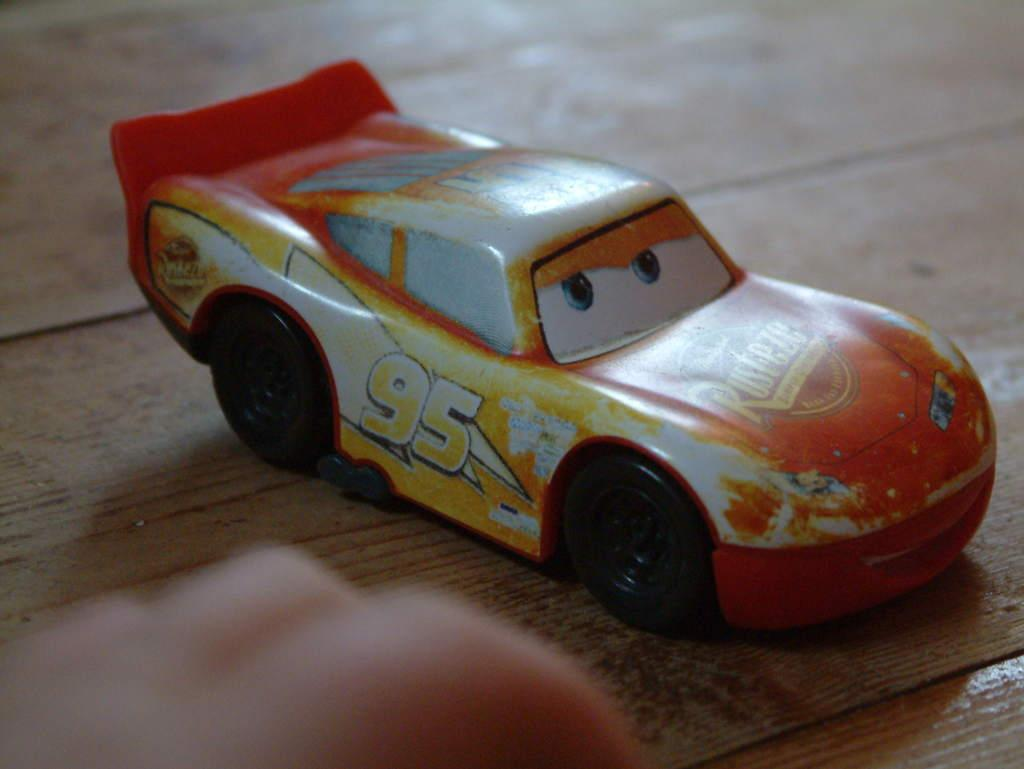What is the main object in the image? There is a toy car in the image. What is the toy car placed on? The toy car is placed on a wooden surface. Can you describe any other visible elements in the image? Human fingers are visible at the bottom of the image. What is the topic of the discussion happening between the toy car and the wooden surface in the image? There is no discussion happening between the toy car and the wooden surface in the image. 